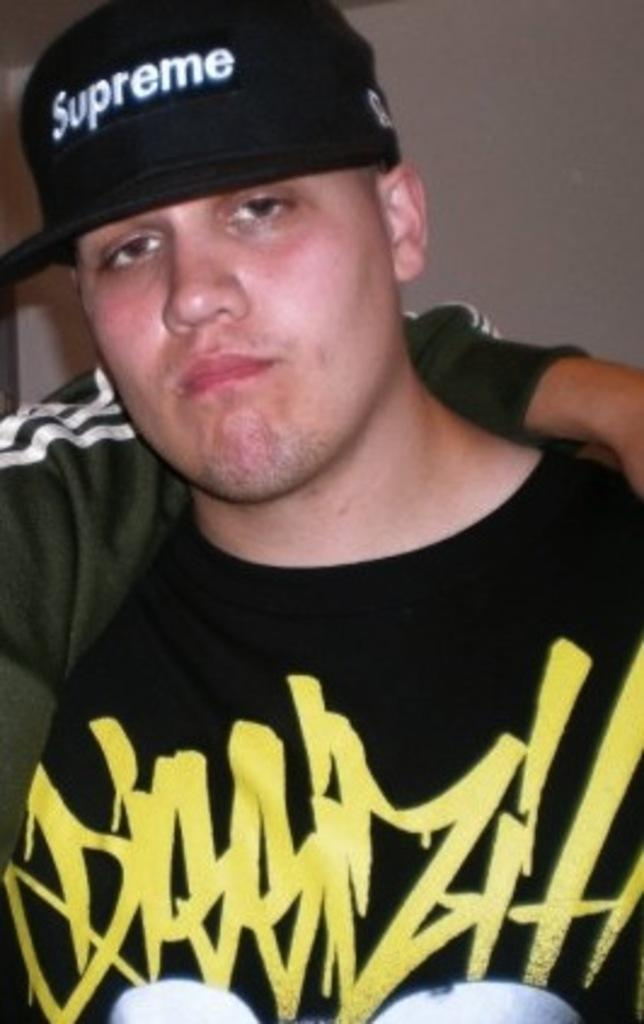<image>
Provide a brief description of the given image. a white male wearing a black shirt with a black hat that says supreme 